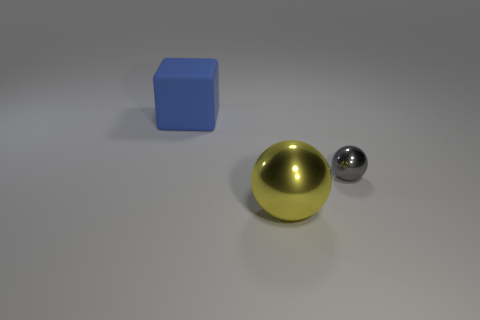There is a small object; is it the same color as the object in front of the gray shiny thing?
Your response must be concise. No. There is a thing that is both to the right of the big rubber cube and left of the small gray ball; what color is it?
Offer a very short reply. Yellow. There is a small gray metal ball; how many gray balls are on the right side of it?
Keep it short and to the point. 0. What number of things are large yellow metallic balls or metallic things that are in front of the gray metallic sphere?
Provide a short and direct response. 1. There is a metal object in front of the gray metal object; are there any big blue rubber blocks in front of it?
Ensure brevity in your answer.  No. What color is the metallic thing behind the big metal object?
Offer a terse response. Gray. Are there the same number of blue rubber cubes on the left side of the large blue thing and tiny green matte cylinders?
Ensure brevity in your answer.  Yes. What is the shape of the object that is both behind the large metallic thing and left of the gray metallic sphere?
Provide a succinct answer. Cube. The other object that is the same shape as the large metal thing is what color?
Your answer should be very brief. Gray. Are there any other things of the same color as the big rubber block?
Your answer should be compact. No. 